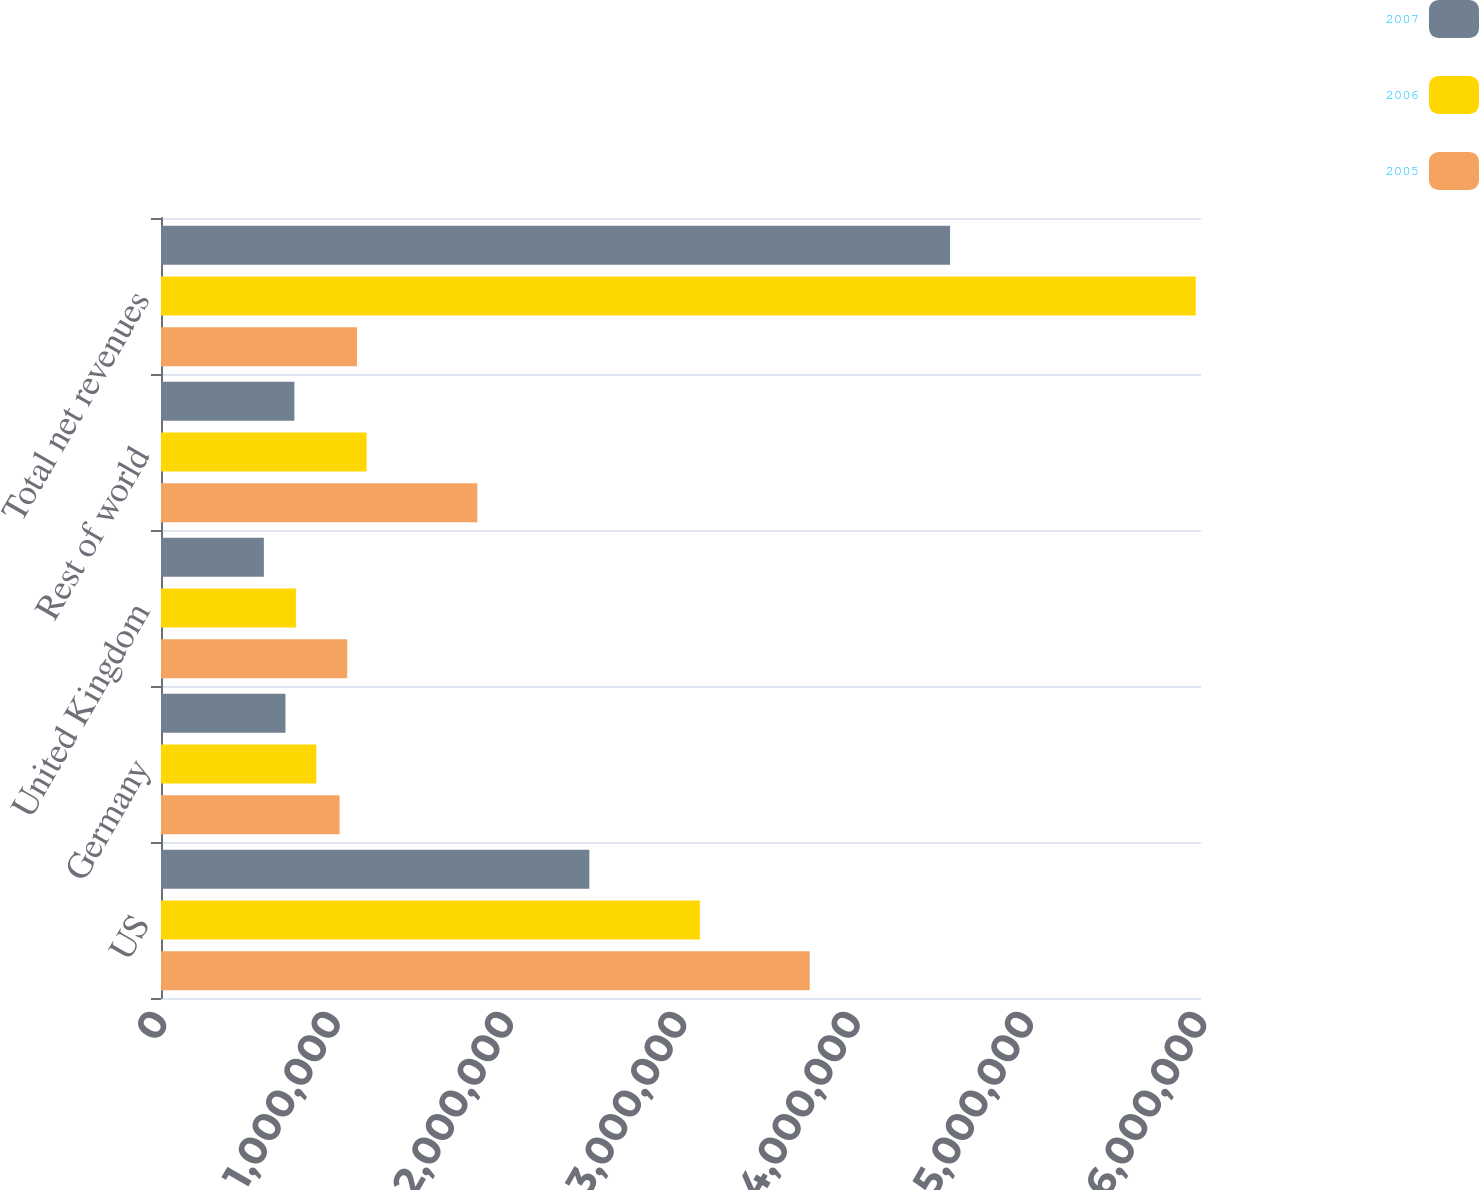Convert chart to OTSL. <chart><loc_0><loc_0><loc_500><loc_500><stacked_bar_chart><ecel><fcel>US<fcel>Germany<fcel>United Kingdom<fcel>Rest of world<fcel>Total net revenues<nl><fcel>2007<fcel>2.47127e+06<fcel>718137<fcel>593423<fcel>769568<fcel>4.5524e+06<nl><fcel>2006<fcel>3.10899e+06<fcel>895993<fcel>778185<fcel>1.18658e+06<fcel>5.96974e+06<nl><fcel>2005<fcel>3.74267e+06<fcel>1.03016e+06<fcel>1.07449e+06<fcel>1.825e+06<fcel>1.13053e+06<nl></chart> 